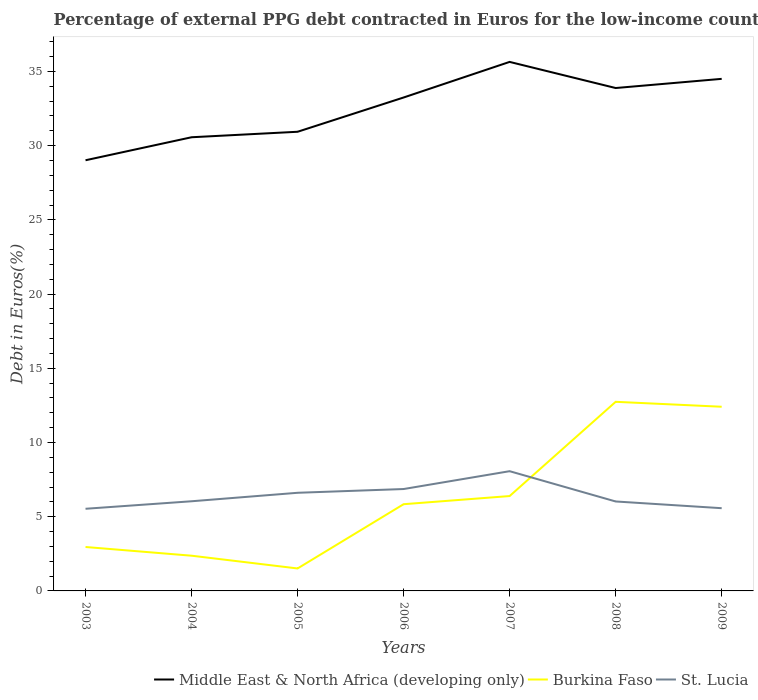How many different coloured lines are there?
Give a very brief answer. 3. Is the number of lines equal to the number of legend labels?
Your answer should be compact. Yes. Across all years, what is the maximum percentage of external PPG debt contracted in Euros in Burkina Faso?
Give a very brief answer. 1.51. In which year was the percentage of external PPG debt contracted in Euros in Burkina Faso maximum?
Your answer should be compact. 2005. What is the total percentage of external PPG debt contracted in Euros in Burkina Faso in the graph?
Ensure brevity in your answer.  -0.55. What is the difference between the highest and the second highest percentage of external PPG debt contracted in Euros in Middle East & North Africa (developing only)?
Your response must be concise. 6.63. How many lines are there?
Your answer should be very brief. 3. How many years are there in the graph?
Make the answer very short. 7. What is the difference between two consecutive major ticks on the Y-axis?
Keep it short and to the point. 5. Does the graph contain any zero values?
Make the answer very short. No. Does the graph contain grids?
Make the answer very short. No. Where does the legend appear in the graph?
Provide a succinct answer. Bottom right. How are the legend labels stacked?
Keep it short and to the point. Horizontal. What is the title of the graph?
Offer a terse response. Percentage of external PPG debt contracted in Euros for the low-income countries. Does "Malta" appear as one of the legend labels in the graph?
Give a very brief answer. No. What is the label or title of the Y-axis?
Provide a succinct answer. Debt in Euros(%). What is the Debt in Euros(%) in Middle East & North Africa (developing only) in 2003?
Make the answer very short. 29.01. What is the Debt in Euros(%) in Burkina Faso in 2003?
Provide a succinct answer. 2.96. What is the Debt in Euros(%) of St. Lucia in 2003?
Give a very brief answer. 5.53. What is the Debt in Euros(%) in Middle East & North Africa (developing only) in 2004?
Ensure brevity in your answer.  30.56. What is the Debt in Euros(%) of Burkina Faso in 2004?
Offer a terse response. 2.37. What is the Debt in Euros(%) of St. Lucia in 2004?
Offer a very short reply. 6.04. What is the Debt in Euros(%) in Middle East & North Africa (developing only) in 2005?
Your answer should be compact. 30.93. What is the Debt in Euros(%) in Burkina Faso in 2005?
Your answer should be very brief. 1.51. What is the Debt in Euros(%) of St. Lucia in 2005?
Provide a short and direct response. 6.61. What is the Debt in Euros(%) of Middle East & North Africa (developing only) in 2006?
Your answer should be very brief. 33.24. What is the Debt in Euros(%) in Burkina Faso in 2006?
Offer a terse response. 5.84. What is the Debt in Euros(%) in St. Lucia in 2006?
Your answer should be very brief. 6.86. What is the Debt in Euros(%) in Middle East & North Africa (developing only) in 2007?
Your answer should be very brief. 35.64. What is the Debt in Euros(%) of Burkina Faso in 2007?
Make the answer very short. 6.39. What is the Debt in Euros(%) in St. Lucia in 2007?
Offer a very short reply. 8.07. What is the Debt in Euros(%) in Middle East & North Africa (developing only) in 2008?
Provide a succinct answer. 33.88. What is the Debt in Euros(%) in Burkina Faso in 2008?
Your answer should be very brief. 12.74. What is the Debt in Euros(%) in St. Lucia in 2008?
Keep it short and to the point. 6.03. What is the Debt in Euros(%) in Middle East & North Africa (developing only) in 2009?
Provide a short and direct response. 34.5. What is the Debt in Euros(%) in Burkina Faso in 2009?
Offer a very short reply. 12.41. What is the Debt in Euros(%) in St. Lucia in 2009?
Give a very brief answer. 5.57. Across all years, what is the maximum Debt in Euros(%) of Middle East & North Africa (developing only)?
Provide a succinct answer. 35.64. Across all years, what is the maximum Debt in Euros(%) of Burkina Faso?
Your answer should be compact. 12.74. Across all years, what is the maximum Debt in Euros(%) of St. Lucia?
Keep it short and to the point. 8.07. Across all years, what is the minimum Debt in Euros(%) in Middle East & North Africa (developing only)?
Your response must be concise. 29.01. Across all years, what is the minimum Debt in Euros(%) in Burkina Faso?
Your answer should be compact. 1.51. Across all years, what is the minimum Debt in Euros(%) of St. Lucia?
Provide a succinct answer. 5.53. What is the total Debt in Euros(%) in Middle East & North Africa (developing only) in the graph?
Your answer should be compact. 227.78. What is the total Debt in Euros(%) of Burkina Faso in the graph?
Make the answer very short. 44.23. What is the total Debt in Euros(%) of St. Lucia in the graph?
Offer a terse response. 44.72. What is the difference between the Debt in Euros(%) in Middle East & North Africa (developing only) in 2003 and that in 2004?
Offer a very short reply. -1.55. What is the difference between the Debt in Euros(%) of Burkina Faso in 2003 and that in 2004?
Offer a terse response. 0.59. What is the difference between the Debt in Euros(%) of St. Lucia in 2003 and that in 2004?
Offer a terse response. -0.51. What is the difference between the Debt in Euros(%) in Middle East & North Africa (developing only) in 2003 and that in 2005?
Provide a succinct answer. -1.92. What is the difference between the Debt in Euros(%) of Burkina Faso in 2003 and that in 2005?
Keep it short and to the point. 1.45. What is the difference between the Debt in Euros(%) in St. Lucia in 2003 and that in 2005?
Give a very brief answer. -1.08. What is the difference between the Debt in Euros(%) of Middle East & North Africa (developing only) in 2003 and that in 2006?
Keep it short and to the point. -4.23. What is the difference between the Debt in Euros(%) of Burkina Faso in 2003 and that in 2006?
Offer a very short reply. -2.88. What is the difference between the Debt in Euros(%) in St. Lucia in 2003 and that in 2006?
Your answer should be very brief. -1.33. What is the difference between the Debt in Euros(%) of Middle East & North Africa (developing only) in 2003 and that in 2007?
Ensure brevity in your answer.  -6.63. What is the difference between the Debt in Euros(%) in Burkina Faso in 2003 and that in 2007?
Give a very brief answer. -3.43. What is the difference between the Debt in Euros(%) of St. Lucia in 2003 and that in 2007?
Ensure brevity in your answer.  -2.53. What is the difference between the Debt in Euros(%) of Middle East & North Africa (developing only) in 2003 and that in 2008?
Your answer should be very brief. -4.87. What is the difference between the Debt in Euros(%) of Burkina Faso in 2003 and that in 2008?
Keep it short and to the point. -9.78. What is the difference between the Debt in Euros(%) of St. Lucia in 2003 and that in 2008?
Your response must be concise. -0.49. What is the difference between the Debt in Euros(%) of Middle East & North Africa (developing only) in 2003 and that in 2009?
Keep it short and to the point. -5.48. What is the difference between the Debt in Euros(%) in Burkina Faso in 2003 and that in 2009?
Provide a short and direct response. -9.45. What is the difference between the Debt in Euros(%) in St. Lucia in 2003 and that in 2009?
Your answer should be very brief. -0.04. What is the difference between the Debt in Euros(%) of Middle East & North Africa (developing only) in 2004 and that in 2005?
Provide a short and direct response. -0.37. What is the difference between the Debt in Euros(%) in Burkina Faso in 2004 and that in 2005?
Your response must be concise. 0.86. What is the difference between the Debt in Euros(%) of St. Lucia in 2004 and that in 2005?
Your answer should be compact. -0.57. What is the difference between the Debt in Euros(%) of Middle East & North Africa (developing only) in 2004 and that in 2006?
Offer a terse response. -2.68. What is the difference between the Debt in Euros(%) of Burkina Faso in 2004 and that in 2006?
Your answer should be very brief. -3.47. What is the difference between the Debt in Euros(%) in St. Lucia in 2004 and that in 2006?
Ensure brevity in your answer.  -0.82. What is the difference between the Debt in Euros(%) of Middle East & North Africa (developing only) in 2004 and that in 2007?
Ensure brevity in your answer.  -5.08. What is the difference between the Debt in Euros(%) of Burkina Faso in 2004 and that in 2007?
Your answer should be very brief. -4.02. What is the difference between the Debt in Euros(%) in St. Lucia in 2004 and that in 2007?
Your answer should be compact. -2.03. What is the difference between the Debt in Euros(%) of Middle East & North Africa (developing only) in 2004 and that in 2008?
Keep it short and to the point. -3.32. What is the difference between the Debt in Euros(%) of Burkina Faso in 2004 and that in 2008?
Offer a very short reply. -10.37. What is the difference between the Debt in Euros(%) of St. Lucia in 2004 and that in 2008?
Keep it short and to the point. 0.01. What is the difference between the Debt in Euros(%) of Middle East & North Africa (developing only) in 2004 and that in 2009?
Your response must be concise. -3.93. What is the difference between the Debt in Euros(%) in Burkina Faso in 2004 and that in 2009?
Provide a short and direct response. -10.04. What is the difference between the Debt in Euros(%) of St. Lucia in 2004 and that in 2009?
Offer a terse response. 0.47. What is the difference between the Debt in Euros(%) of Middle East & North Africa (developing only) in 2005 and that in 2006?
Keep it short and to the point. -2.31. What is the difference between the Debt in Euros(%) of Burkina Faso in 2005 and that in 2006?
Give a very brief answer. -4.33. What is the difference between the Debt in Euros(%) in St. Lucia in 2005 and that in 2006?
Ensure brevity in your answer.  -0.25. What is the difference between the Debt in Euros(%) of Middle East & North Africa (developing only) in 2005 and that in 2007?
Keep it short and to the point. -4.71. What is the difference between the Debt in Euros(%) in Burkina Faso in 2005 and that in 2007?
Ensure brevity in your answer.  -4.88. What is the difference between the Debt in Euros(%) of St. Lucia in 2005 and that in 2007?
Keep it short and to the point. -1.46. What is the difference between the Debt in Euros(%) in Middle East & North Africa (developing only) in 2005 and that in 2008?
Provide a short and direct response. -2.95. What is the difference between the Debt in Euros(%) in Burkina Faso in 2005 and that in 2008?
Make the answer very short. -11.23. What is the difference between the Debt in Euros(%) of St. Lucia in 2005 and that in 2008?
Offer a very short reply. 0.58. What is the difference between the Debt in Euros(%) in Middle East & North Africa (developing only) in 2005 and that in 2009?
Make the answer very short. -3.56. What is the difference between the Debt in Euros(%) of Burkina Faso in 2005 and that in 2009?
Your response must be concise. -10.9. What is the difference between the Debt in Euros(%) in St. Lucia in 2005 and that in 2009?
Your response must be concise. 1.04. What is the difference between the Debt in Euros(%) in Middle East & North Africa (developing only) in 2006 and that in 2007?
Give a very brief answer. -2.4. What is the difference between the Debt in Euros(%) in Burkina Faso in 2006 and that in 2007?
Offer a very short reply. -0.55. What is the difference between the Debt in Euros(%) in St. Lucia in 2006 and that in 2007?
Provide a succinct answer. -1.2. What is the difference between the Debt in Euros(%) of Middle East & North Africa (developing only) in 2006 and that in 2008?
Make the answer very short. -0.64. What is the difference between the Debt in Euros(%) of Burkina Faso in 2006 and that in 2008?
Your answer should be compact. -6.9. What is the difference between the Debt in Euros(%) in St. Lucia in 2006 and that in 2008?
Make the answer very short. 0.84. What is the difference between the Debt in Euros(%) of Middle East & North Africa (developing only) in 2006 and that in 2009?
Offer a very short reply. -1.26. What is the difference between the Debt in Euros(%) in Burkina Faso in 2006 and that in 2009?
Ensure brevity in your answer.  -6.57. What is the difference between the Debt in Euros(%) of St. Lucia in 2006 and that in 2009?
Provide a succinct answer. 1.29. What is the difference between the Debt in Euros(%) in Middle East & North Africa (developing only) in 2007 and that in 2008?
Offer a terse response. 1.76. What is the difference between the Debt in Euros(%) of Burkina Faso in 2007 and that in 2008?
Keep it short and to the point. -6.35. What is the difference between the Debt in Euros(%) of St. Lucia in 2007 and that in 2008?
Ensure brevity in your answer.  2.04. What is the difference between the Debt in Euros(%) in Middle East & North Africa (developing only) in 2007 and that in 2009?
Your answer should be compact. 1.14. What is the difference between the Debt in Euros(%) in Burkina Faso in 2007 and that in 2009?
Your answer should be compact. -6.02. What is the difference between the Debt in Euros(%) of St. Lucia in 2007 and that in 2009?
Provide a succinct answer. 2.49. What is the difference between the Debt in Euros(%) in Middle East & North Africa (developing only) in 2008 and that in 2009?
Keep it short and to the point. -0.62. What is the difference between the Debt in Euros(%) of Burkina Faso in 2008 and that in 2009?
Give a very brief answer. 0.33. What is the difference between the Debt in Euros(%) in St. Lucia in 2008 and that in 2009?
Provide a succinct answer. 0.45. What is the difference between the Debt in Euros(%) of Middle East & North Africa (developing only) in 2003 and the Debt in Euros(%) of Burkina Faso in 2004?
Make the answer very short. 26.64. What is the difference between the Debt in Euros(%) in Middle East & North Africa (developing only) in 2003 and the Debt in Euros(%) in St. Lucia in 2004?
Provide a succinct answer. 22.97. What is the difference between the Debt in Euros(%) in Burkina Faso in 2003 and the Debt in Euros(%) in St. Lucia in 2004?
Your answer should be very brief. -3.08. What is the difference between the Debt in Euros(%) of Middle East & North Africa (developing only) in 2003 and the Debt in Euros(%) of Burkina Faso in 2005?
Provide a short and direct response. 27.5. What is the difference between the Debt in Euros(%) in Middle East & North Africa (developing only) in 2003 and the Debt in Euros(%) in St. Lucia in 2005?
Ensure brevity in your answer.  22.4. What is the difference between the Debt in Euros(%) in Burkina Faso in 2003 and the Debt in Euros(%) in St. Lucia in 2005?
Provide a short and direct response. -3.65. What is the difference between the Debt in Euros(%) in Middle East & North Africa (developing only) in 2003 and the Debt in Euros(%) in Burkina Faso in 2006?
Ensure brevity in your answer.  23.17. What is the difference between the Debt in Euros(%) in Middle East & North Africa (developing only) in 2003 and the Debt in Euros(%) in St. Lucia in 2006?
Make the answer very short. 22.15. What is the difference between the Debt in Euros(%) in Burkina Faso in 2003 and the Debt in Euros(%) in St. Lucia in 2006?
Your answer should be compact. -3.9. What is the difference between the Debt in Euros(%) of Middle East & North Africa (developing only) in 2003 and the Debt in Euros(%) of Burkina Faso in 2007?
Your answer should be very brief. 22.62. What is the difference between the Debt in Euros(%) in Middle East & North Africa (developing only) in 2003 and the Debt in Euros(%) in St. Lucia in 2007?
Offer a very short reply. 20.95. What is the difference between the Debt in Euros(%) in Burkina Faso in 2003 and the Debt in Euros(%) in St. Lucia in 2007?
Your answer should be very brief. -5.11. What is the difference between the Debt in Euros(%) in Middle East & North Africa (developing only) in 2003 and the Debt in Euros(%) in Burkina Faso in 2008?
Provide a succinct answer. 16.27. What is the difference between the Debt in Euros(%) in Middle East & North Africa (developing only) in 2003 and the Debt in Euros(%) in St. Lucia in 2008?
Give a very brief answer. 22.99. What is the difference between the Debt in Euros(%) of Burkina Faso in 2003 and the Debt in Euros(%) of St. Lucia in 2008?
Provide a succinct answer. -3.07. What is the difference between the Debt in Euros(%) in Middle East & North Africa (developing only) in 2003 and the Debt in Euros(%) in Burkina Faso in 2009?
Provide a succinct answer. 16.61. What is the difference between the Debt in Euros(%) in Middle East & North Africa (developing only) in 2003 and the Debt in Euros(%) in St. Lucia in 2009?
Make the answer very short. 23.44. What is the difference between the Debt in Euros(%) of Burkina Faso in 2003 and the Debt in Euros(%) of St. Lucia in 2009?
Keep it short and to the point. -2.61. What is the difference between the Debt in Euros(%) in Middle East & North Africa (developing only) in 2004 and the Debt in Euros(%) in Burkina Faso in 2005?
Ensure brevity in your answer.  29.05. What is the difference between the Debt in Euros(%) in Middle East & North Africa (developing only) in 2004 and the Debt in Euros(%) in St. Lucia in 2005?
Your response must be concise. 23.95. What is the difference between the Debt in Euros(%) in Burkina Faso in 2004 and the Debt in Euros(%) in St. Lucia in 2005?
Your answer should be compact. -4.24. What is the difference between the Debt in Euros(%) in Middle East & North Africa (developing only) in 2004 and the Debt in Euros(%) in Burkina Faso in 2006?
Your response must be concise. 24.72. What is the difference between the Debt in Euros(%) of Middle East & North Africa (developing only) in 2004 and the Debt in Euros(%) of St. Lucia in 2006?
Offer a terse response. 23.7. What is the difference between the Debt in Euros(%) of Burkina Faso in 2004 and the Debt in Euros(%) of St. Lucia in 2006?
Keep it short and to the point. -4.49. What is the difference between the Debt in Euros(%) in Middle East & North Africa (developing only) in 2004 and the Debt in Euros(%) in Burkina Faso in 2007?
Provide a short and direct response. 24.17. What is the difference between the Debt in Euros(%) in Middle East & North Africa (developing only) in 2004 and the Debt in Euros(%) in St. Lucia in 2007?
Ensure brevity in your answer.  22.5. What is the difference between the Debt in Euros(%) in Burkina Faso in 2004 and the Debt in Euros(%) in St. Lucia in 2007?
Keep it short and to the point. -5.69. What is the difference between the Debt in Euros(%) in Middle East & North Africa (developing only) in 2004 and the Debt in Euros(%) in Burkina Faso in 2008?
Keep it short and to the point. 17.82. What is the difference between the Debt in Euros(%) in Middle East & North Africa (developing only) in 2004 and the Debt in Euros(%) in St. Lucia in 2008?
Your answer should be compact. 24.54. What is the difference between the Debt in Euros(%) of Burkina Faso in 2004 and the Debt in Euros(%) of St. Lucia in 2008?
Keep it short and to the point. -3.65. What is the difference between the Debt in Euros(%) of Middle East & North Africa (developing only) in 2004 and the Debt in Euros(%) of Burkina Faso in 2009?
Provide a short and direct response. 18.16. What is the difference between the Debt in Euros(%) in Middle East & North Africa (developing only) in 2004 and the Debt in Euros(%) in St. Lucia in 2009?
Provide a succinct answer. 24.99. What is the difference between the Debt in Euros(%) of Burkina Faso in 2004 and the Debt in Euros(%) of St. Lucia in 2009?
Give a very brief answer. -3.2. What is the difference between the Debt in Euros(%) in Middle East & North Africa (developing only) in 2005 and the Debt in Euros(%) in Burkina Faso in 2006?
Ensure brevity in your answer.  25.09. What is the difference between the Debt in Euros(%) in Middle East & North Africa (developing only) in 2005 and the Debt in Euros(%) in St. Lucia in 2006?
Make the answer very short. 24.07. What is the difference between the Debt in Euros(%) in Burkina Faso in 2005 and the Debt in Euros(%) in St. Lucia in 2006?
Ensure brevity in your answer.  -5.35. What is the difference between the Debt in Euros(%) in Middle East & North Africa (developing only) in 2005 and the Debt in Euros(%) in Burkina Faso in 2007?
Offer a very short reply. 24.54. What is the difference between the Debt in Euros(%) of Middle East & North Africa (developing only) in 2005 and the Debt in Euros(%) of St. Lucia in 2007?
Your response must be concise. 22.87. What is the difference between the Debt in Euros(%) in Burkina Faso in 2005 and the Debt in Euros(%) in St. Lucia in 2007?
Your answer should be compact. -6.55. What is the difference between the Debt in Euros(%) of Middle East & North Africa (developing only) in 2005 and the Debt in Euros(%) of Burkina Faso in 2008?
Provide a succinct answer. 18.19. What is the difference between the Debt in Euros(%) in Middle East & North Africa (developing only) in 2005 and the Debt in Euros(%) in St. Lucia in 2008?
Keep it short and to the point. 24.91. What is the difference between the Debt in Euros(%) of Burkina Faso in 2005 and the Debt in Euros(%) of St. Lucia in 2008?
Provide a succinct answer. -4.51. What is the difference between the Debt in Euros(%) in Middle East & North Africa (developing only) in 2005 and the Debt in Euros(%) in Burkina Faso in 2009?
Provide a succinct answer. 18.53. What is the difference between the Debt in Euros(%) of Middle East & North Africa (developing only) in 2005 and the Debt in Euros(%) of St. Lucia in 2009?
Offer a terse response. 25.36. What is the difference between the Debt in Euros(%) in Burkina Faso in 2005 and the Debt in Euros(%) in St. Lucia in 2009?
Ensure brevity in your answer.  -4.06. What is the difference between the Debt in Euros(%) in Middle East & North Africa (developing only) in 2006 and the Debt in Euros(%) in Burkina Faso in 2007?
Keep it short and to the point. 26.85. What is the difference between the Debt in Euros(%) in Middle East & North Africa (developing only) in 2006 and the Debt in Euros(%) in St. Lucia in 2007?
Make the answer very short. 25.18. What is the difference between the Debt in Euros(%) of Burkina Faso in 2006 and the Debt in Euros(%) of St. Lucia in 2007?
Provide a succinct answer. -2.22. What is the difference between the Debt in Euros(%) of Middle East & North Africa (developing only) in 2006 and the Debt in Euros(%) of Burkina Faso in 2008?
Your response must be concise. 20.5. What is the difference between the Debt in Euros(%) of Middle East & North Africa (developing only) in 2006 and the Debt in Euros(%) of St. Lucia in 2008?
Provide a short and direct response. 27.22. What is the difference between the Debt in Euros(%) in Burkina Faso in 2006 and the Debt in Euros(%) in St. Lucia in 2008?
Ensure brevity in your answer.  -0.18. What is the difference between the Debt in Euros(%) of Middle East & North Africa (developing only) in 2006 and the Debt in Euros(%) of Burkina Faso in 2009?
Ensure brevity in your answer.  20.83. What is the difference between the Debt in Euros(%) in Middle East & North Africa (developing only) in 2006 and the Debt in Euros(%) in St. Lucia in 2009?
Offer a very short reply. 27.67. What is the difference between the Debt in Euros(%) of Burkina Faso in 2006 and the Debt in Euros(%) of St. Lucia in 2009?
Keep it short and to the point. 0.27. What is the difference between the Debt in Euros(%) of Middle East & North Africa (developing only) in 2007 and the Debt in Euros(%) of Burkina Faso in 2008?
Your answer should be compact. 22.9. What is the difference between the Debt in Euros(%) in Middle East & North Africa (developing only) in 2007 and the Debt in Euros(%) in St. Lucia in 2008?
Your answer should be compact. 29.61. What is the difference between the Debt in Euros(%) of Burkina Faso in 2007 and the Debt in Euros(%) of St. Lucia in 2008?
Your answer should be compact. 0.37. What is the difference between the Debt in Euros(%) of Middle East & North Africa (developing only) in 2007 and the Debt in Euros(%) of Burkina Faso in 2009?
Provide a short and direct response. 23.23. What is the difference between the Debt in Euros(%) of Middle East & North Africa (developing only) in 2007 and the Debt in Euros(%) of St. Lucia in 2009?
Your answer should be compact. 30.07. What is the difference between the Debt in Euros(%) in Burkina Faso in 2007 and the Debt in Euros(%) in St. Lucia in 2009?
Your answer should be very brief. 0.82. What is the difference between the Debt in Euros(%) in Middle East & North Africa (developing only) in 2008 and the Debt in Euros(%) in Burkina Faso in 2009?
Your answer should be very brief. 21.47. What is the difference between the Debt in Euros(%) of Middle East & North Africa (developing only) in 2008 and the Debt in Euros(%) of St. Lucia in 2009?
Make the answer very short. 28.31. What is the difference between the Debt in Euros(%) in Burkina Faso in 2008 and the Debt in Euros(%) in St. Lucia in 2009?
Provide a short and direct response. 7.17. What is the average Debt in Euros(%) of Middle East & North Africa (developing only) per year?
Ensure brevity in your answer.  32.54. What is the average Debt in Euros(%) in Burkina Faso per year?
Keep it short and to the point. 6.32. What is the average Debt in Euros(%) in St. Lucia per year?
Offer a very short reply. 6.39. In the year 2003, what is the difference between the Debt in Euros(%) in Middle East & North Africa (developing only) and Debt in Euros(%) in Burkina Faso?
Offer a terse response. 26.05. In the year 2003, what is the difference between the Debt in Euros(%) of Middle East & North Africa (developing only) and Debt in Euros(%) of St. Lucia?
Your answer should be compact. 23.48. In the year 2003, what is the difference between the Debt in Euros(%) of Burkina Faso and Debt in Euros(%) of St. Lucia?
Offer a terse response. -2.57. In the year 2004, what is the difference between the Debt in Euros(%) in Middle East & North Africa (developing only) and Debt in Euros(%) in Burkina Faso?
Provide a succinct answer. 28.19. In the year 2004, what is the difference between the Debt in Euros(%) of Middle East & North Africa (developing only) and Debt in Euros(%) of St. Lucia?
Your answer should be compact. 24.52. In the year 2004, what is the difference between the Debt in Euros(%) in Burkina Faso and Debt in Euros(%) in St. Lucia?
Provide a short and direct response. -3.67. In the year 2005, what is the difference between the Debt in Euros(%) in Middle East & North Africa (developing only) and Debt in Euros(%) in Burkina Faso?
Give a very brief answer. 29.42. In the year 2005, what is the difference between the Debt in Euros(%) in Middle East & North Africa (developing only) and Debt in Euros(%) in St. Lucia?
Give a very brief answer. 24.32. In the year 2005, what is the difference between the Debt in Euros(%) of Burkina Faso and Debt in Euros(%) of St. Lucia?
Ensure brevity in your answer.  -5.1. In the year 2006, what is the difference between the Debt in Euros(%) in Middle East & North Africa (developing only) and Debt in Euros(%) in Burkina Faso?
Offer a terse response. 27.4. In the year 2006, what is the difference between the Debt in Euros(%) in Middle East & North Africa (developing only) and Debt in Euros(%) in St. Lucia?
Offer a very short reply. 26.38. In the year 2006, what is the difference between the Debt in Euros(%) in Burkina Faso and Debt in Euros(%) in St. Lucia?
Give a very brief answer. -1.02. In the year 2007, what is the difference between the Debt in Euros(%) of Middle East & North Africa (developing only) and Debt in Euros(%) of Burkina Faso?
Make the answer very short. 29.25. In the year 2007, what is the difference between the Debt in Euros(%) in Middle East & North Africa (developing only) and Debt in Euros(%) in St. Lucia?
Your response must be concise. 27.57. In the year 2007, what is the difference between the Debt in Euros(%) of Burkina Faso and Debt in Euros(%) of St. Lucia?
Offer a very short reply. -1.67. In the year 2008, what is the difference between the Debt in Euros(%) of Middle East & North Africa (developing only) and Debt in Euros(%) of Burkina Faso?
Ensure brevity in your answer.  21.14. In the year 2008, what is the difference between the Debt in Euros(%) in Middle East & North Africa (developing only) and Debt in Euros(%) in St. Lucia?
Offer a very short reply. 27.85. In the year 2008, what is the difference between the Debt in Euros(%) in Burkina Faso and Debt in Euros(%) in St. Lucia?
Provide a succinct answer. 6.71. In the year 2009, what is the difference between the Debt in Euros(%) of Middle East & North Africa (developing only) and Debt in Euros(%) of Burkina Faso?
Offer a terse response. 22.09. In the year 2009, what is the difference between the Debt in Euros(%) in Middle East & North Africa (developing only) and Debt in Euros(%) in St. Lucia?
Your answer should be compact. 28.93. In the year 2009, what is the difference between the Debt in Euros(%) of Burkina Faso and Debt in Euros(%) of St. Lucia?
Your answer should be very brief. 6.83. What is the ratio of the Debt in Euros(%) of Middle East & North Africa (developing only) in 2003 to that in 2004?
Your response must be concise. 0.95. What is the ratio of the Debt in Euros(%) of Burkina Faso in 2003 to that in 2004?
Your answer should be very brief. 1.25. What is the ratio of the Debt in Euros(%) in St. Lucia in 2003 to that in 2004?
Your response must be concise. 0.92. What is the ratio of the Debt in Euros(%) of Middle East & North Africa (developing only) in 2003 to that in 2005?
Your answer should be compact. 0.94. What is the ratio of the Debt in Euros(%) in Burkina Faso in 2003 to that in 2005?
Provide a succinct answer. 1.96. What is the ratio of the Debt in Euros(%) in St. Lucia in 2003 to that in 2005?
Offer a terse response. 0.84. What is the ratio of the Debt in Euros(%) in Middle East & North Africa (developing only) in 2003 to that in 2006?
Offer a very short reply. 0.87. What is the ratio of the Debt in Euros(%) in Burkina Faso in 2003 to that in 2006?
Offer a very short reply. 0.51. What is the ratio of the Debt in Euros(%) in St. Lucia in 2003 to that in 2006?
Provide a succinct answer. 0.81. What is the ratio of the Debt in Euros(%) of Middle East & North Africa (developing only) in 2003 to that in 2007?
Make the answer very short. 0.81. What is the ratio of the Debt in Euros(%) in Burkina Faso in 2003 to that in 2007?
Ensure brevity in your answer.  0.46. What is the ratio of the Debt in Euros(%) of St. Lucia in 2003 to that in 2007?
Provide a succinct answer. 0.69. What is the ratio of the Debt in Euros(%) in Middle East & North Africa (developing only) in 2003 to that in 2008?
Your response must be concise. 0.86. What is the ratio of the Debt in Euros(%) in Burkina Faso in 2003 to that in 2008?
Make the answer very short. 0.23. What is the ratio of the Debt in Euros(%) of St. Lucia in 2003 to that in 2008?
Ensure brevity in your answer.  0.92. What is the ratio of the Debt in Euros(%) of Middle East & North Africa (developing only) in 2003 to that in 2009?
Your response must be concise. 0.84. What is the ratio of the Debt in Euros(%) in Burkina Faso in 2003 to that in 2009?
Give a very brief answer. 0.24. What is the ratio of the Debt in Euros(%) of St. Lucia in 2003 to that in 2009?
Make the answer very short. 0.99. What is the ratio of the Debt in Euros(%) of Middle East & North Africa (developing only) in 2004 to that in 2005?
Offer a terse response. 0.99. What is the ratio of the Debt in Euros(%) of Burkina Faso in 2004 to that in 2005?
Ensure brevity in your answer.  1.57. What is the ratio of the Debt in Euros(%) in St. Lucia in 2004 to that in 2005?
Keep it short and to the point. 0.91. What is the ratio of the Debt in Euros(%) in Middle East & North Africa (developing only) in 2004 to that in 2006?
Keep it short and to the point. 0.92. What is the ratio of the Debt in Euros(%) of Burkina Faso in 2004 to that in 2006?
Ensure brevity in your answer.  0.41. What is the ratio of the Debt in Euros(%) of St. Lucia in 2004 to that in 2006?
Keep it short and to the point. 0.88. What is the ratio of the Debt in Euros(%) in Middle East & North Africa (developing only) in 2004 to that in 2007?
Give a very brief answer. 0.86. What is the ratio of the Debt in Euros(%) in Burkina Faso in 2004 to that in 2007?
Keep it short and to the point. 0.37. What is the ratio of the Debt in Euros(%) of St. Lucia in 2004 to that in 2007?
Make the answer very short. 0.75. What is the ratio of the Debt in Euros(%) in Middle East & North Africa (developing only) in 2004 to that in 2008?
Your response must be concise. 0.9. What is the ratio of the Debt in Euros(%) of Burkina Faso in 2004 to that in 2008?
Keep it short and to the point. 0.19. What is the ratio of the Debt in Euros(%) in Middle East & North Africa (developing only) in 2004 to that in 2009?
Keep it short and to the point. 0.89. What is the ratio of the Debt in Euros(%) in Burkina Faso in 2004 to that in 2009?
Your answer should be very brief. 0.19. What is the ratio of the Debt in Euros(%) of St. Lucia in 2004 to that in 2009?
Keep it short and to the point. 1.08. What is the ratio of the Debt in Euros(%) in Middle East & North Africa (developing only) in 2005 to that in 2006?
Provide a succinct answer. 0.93. What is the ratio of the Debt in Euros(%) in Burkina Faso in 2005 to that in 2006?
Make the answer very short. 0.26. What is the ratio of the Debt in Euros(%) of St. Lucia in 2005 to that in 2006?
Your response must be concise. 0.96. What is the ratio of the Debt in Euros(%) in Middle East & North Africa (developing only) in 2005 to that in 2007?
Provide a short and direct response. 0.87. What is the ratio of the Debt in Euros(%) of Burkina Faso in 2005 to that in 2007?
Your answer should be compact. 0.24. What is the ratio of the Debt in Euros(%) of St. Lucia in 2005 to that in 2007?
Offer a terse response. 0.82. What is the ratio of the Debt in Euros(%) in Burkina Faso in 2005 to that in 2008?
Provide a succinct answer. 0.12. What is the ratio of the Debt in Euros(%) in St. Lucia in 2005 to that in 2008?
Keep it short and to the point. 1.1. What is the ratio of the Debt in Euros(%) in Middle East & North Africa (developing only) in 2005 to that in 2009?
Provide a succinct answer. 0.9. What is the ratio of the Debt in Euros(%) of Burkina Faso in 2005 to that in 2009?
Offer a terse response. 0.12. What is the ratio of the Debt in Euros(%) in St. Lucia in 2005 to that in 2009?
Offer a terse response. 1.19. What is the ratio of the Debt in Euros(%) of Middle East & North Africa (developing only) in 2006 to that in 2007?
Your response must be concise. 0.93. What is the ratio of the Debt in Euros(%) in Burkina Faso in 2006 to that in 2007?
Keep it short and to the point. 0.91. What is the ratio of the Debt in Euros(%) in St. Lucia in 2006 to that in 2007?
Give a very brief answer. 0.85. What is the ratio of the Debt in Euros(%) of Middle East & North Africa (developing only) in 2006 to that in 2008?
Your response must be concise. 0.98. What is the ratio of the Debt in Euros(%) in Burkina Faso in 2006 to that in 2008?
Give a very brief answer. 0.46. What is the ratio of the Debt in Euros(%) of St. Lucia in 2006 to that in 2008?
Give a very brief answer. 1.14. What is the ratio of the Debt in Euros(%) in Middle East & North Africa (developing only) in 2006 to that in 2009?
Your answer should be very brief. 0.96. What is the ratio of the Debt in Euros(%) of Burkina Faso in 2006 to that in 2009?
Make the answer very short. 0.47. What is the ratio of the Debt in Euros(%) in St. Lucia in 2006 to that in 2009?
Keep it short and to the point. 1.23. What is the ratio of the Debt in Euros(%) in Middle East & North Africa (developing only) in 2007 to that in 2008?
Keep it short and to the point. 1.05. What is the ratio of the Debt in Euros(%) of Burkina Faso in 2007 to that in 2008?
Offer a terse response. 0.5. What is the ratio of the Debt in Euros(%) of St. Lucia in 2007 to that in 2008?
Make the answer very short. 1.34. What is the ratio of the Debt in Euros(%) of Middle East & North Africa (developing only) in 2007 to that in 2009?
Provide a short and direct response. 1.03. What is the ratio of the Debt in Euros(%) in Burkina Faso in 2007 to that in 2009?
Offer a very short reply. 0.52. What is the ratio of the Debt in Euros(%) of St. Lucia in 2007 to that in 2009?
Offer a terse response. 1.45. What is the ratio of the Debt in Euros(%) in Middle East & North Africa (developing only) in 2008 to that in 2009?
Offer a terse response. 0.98. What is the ratio of the Debt in Euros(%) in Burkina Faso in 2008 to that in 2009?
Keep it short and to the point. 1.03. What is the ratio of the Debt in Euros(%) of St. Lucia in 2008 to that in 2009?
Provide a short and direct response. 1.08. What is the difference between the highest and the second highest Debt in Euros(%) of Middle East & North Africa (developing only)?
Your answer should be very brief. 1.14. What is the difference between the highest and the second highest Debt in Euros(%) in Burkina Faso?
Your answer should be very brief. 0.33. What is the difference between the highest and the second highest Debt in Euros(%) of St. Lucia?
Make the answer very short. 1.2. What is the difference between the highest and the lowest Debt in Euros(%) of Middle East & North Africa (developing only)?
Your response must be concise. 6.63. What is the difference between the highest and the lowest Debt in Euros(%) of Burkina Faso?
Make the answer very short. 11.23. What is the difference between the highest and the lowest Debt in Euros(%) in St. Lucia?
Your answer should be very brief. 2.53. 